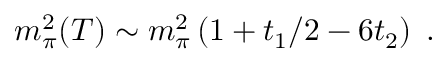<formula> <loc_0><loc_0><loc_500><loc_500>m _ { \pi } ^ { 2 } ( T ) \sim m _ { \pi } ^ { 2 } \left ( 1 + t _ { 1 } / 2 - 6 t _ { 2 } \right ) \, .</formula> 